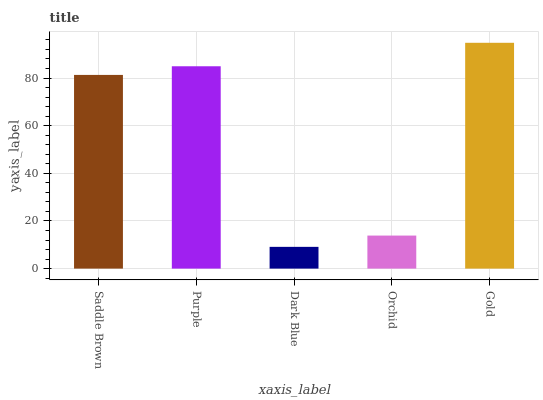Is Dark Blue the minimum?
Answer yes or no. Yes. Is Gold the maximum?
Answer yes or no. Yes. Is Purple the minimum?
Answer yes or no. No. Is Purple the maximum?
Answer yes or no. No. Is Purple greater than Saddle Brown?
Answer yes or no. Yes. Is Saddle Brown less than Purple?
Answer yes or no. Yes. Is Saddle Brown greater than Purple?
Answer yes or no. No. Is Purple less than Saddle Brown?
Answer yes or no. No. Is Saddle Brown the high median?
Answer yes or no. Yes. Is Saddle Brown the low median?
Answer yes or no. Yes. Is Purple the high median?
Answer yes or no. No. Is Purple the low median?
Answer yes or no. No. 